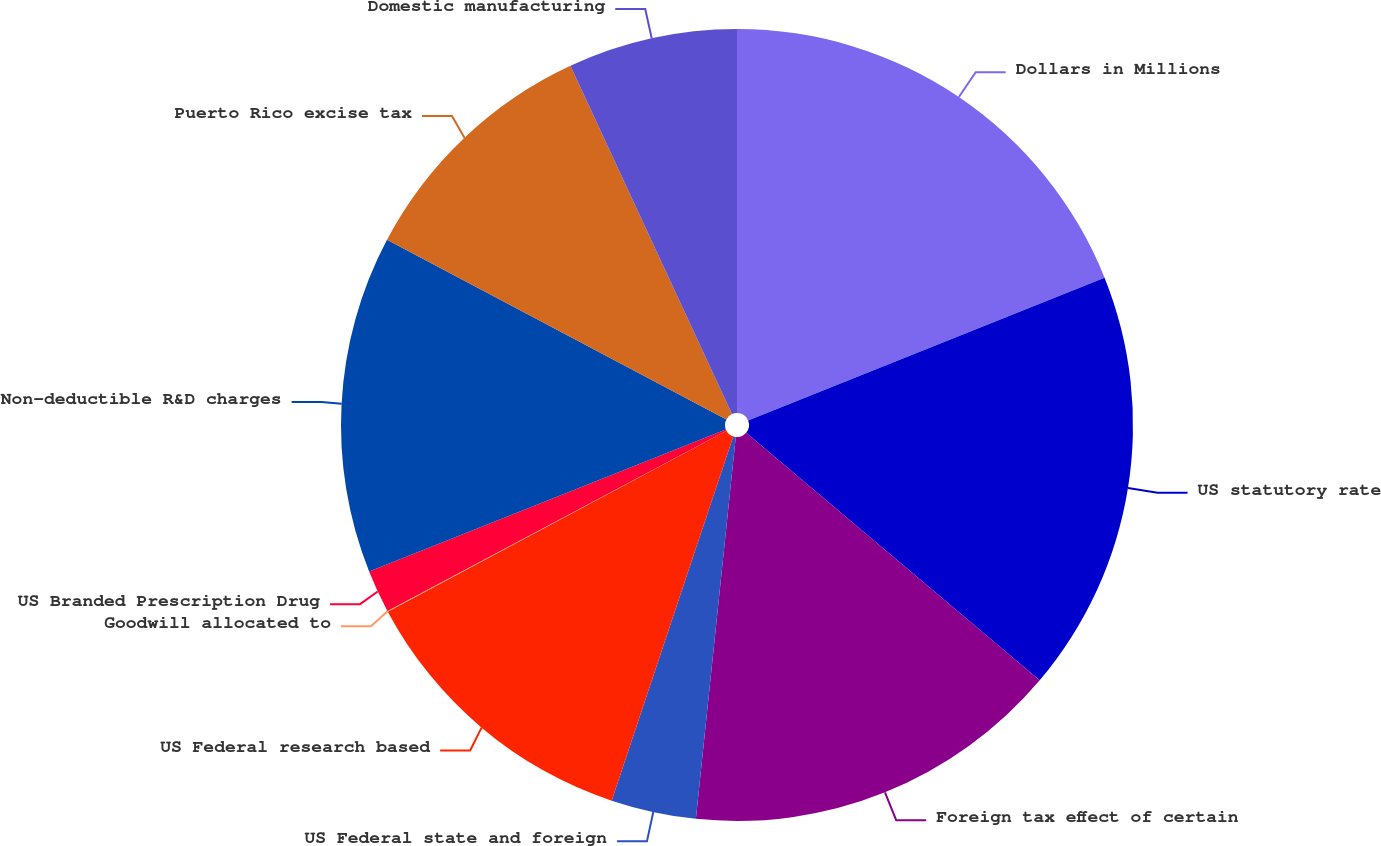Convert chart. <chart><loc_0><loc_0><loc_500><loc_500><pie_chart><fcel>Dollars in Millions<fcel>US statutory rate<fcel>Foreign tax effect of certain<fcel>US Federal state and foreign<fcel>US Federal research based<fcel>Goodwill allocated to<fcel>US Branded Prescription Drug<fcel>Non-deductible R&D charges<fcel>Puerto Rico excise tax<fcel>Domestic manufacturing<nl><fcel>18.93%<fcel>17.22%<fcel>15.5%<fcel>3.47%<fcel>12.06%<fcel>0.03%<fcel>1.75%<fcel>13.78%<fcel>10.34%<fcel>6.91%<nl></chart> 